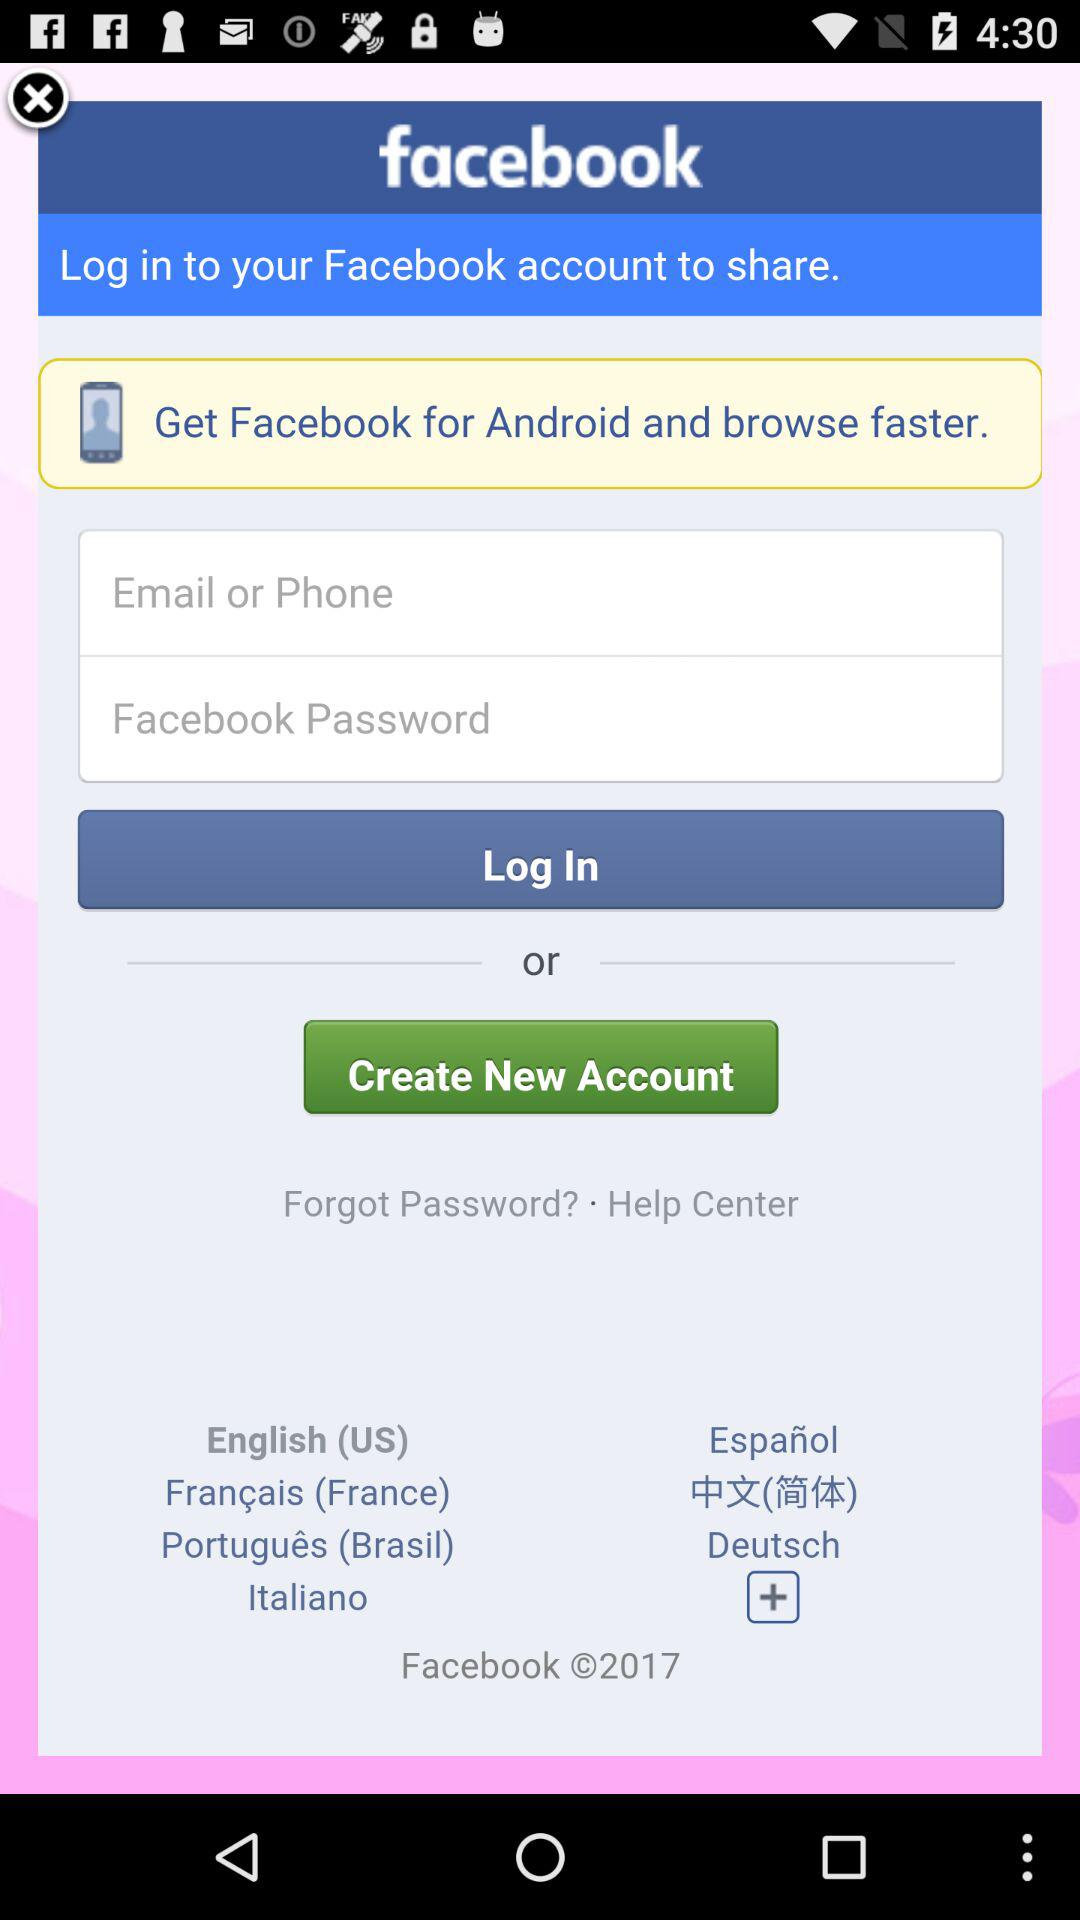How many languages are available in the language selection dropdown?
Answer the question using a single word or phrase. 7 